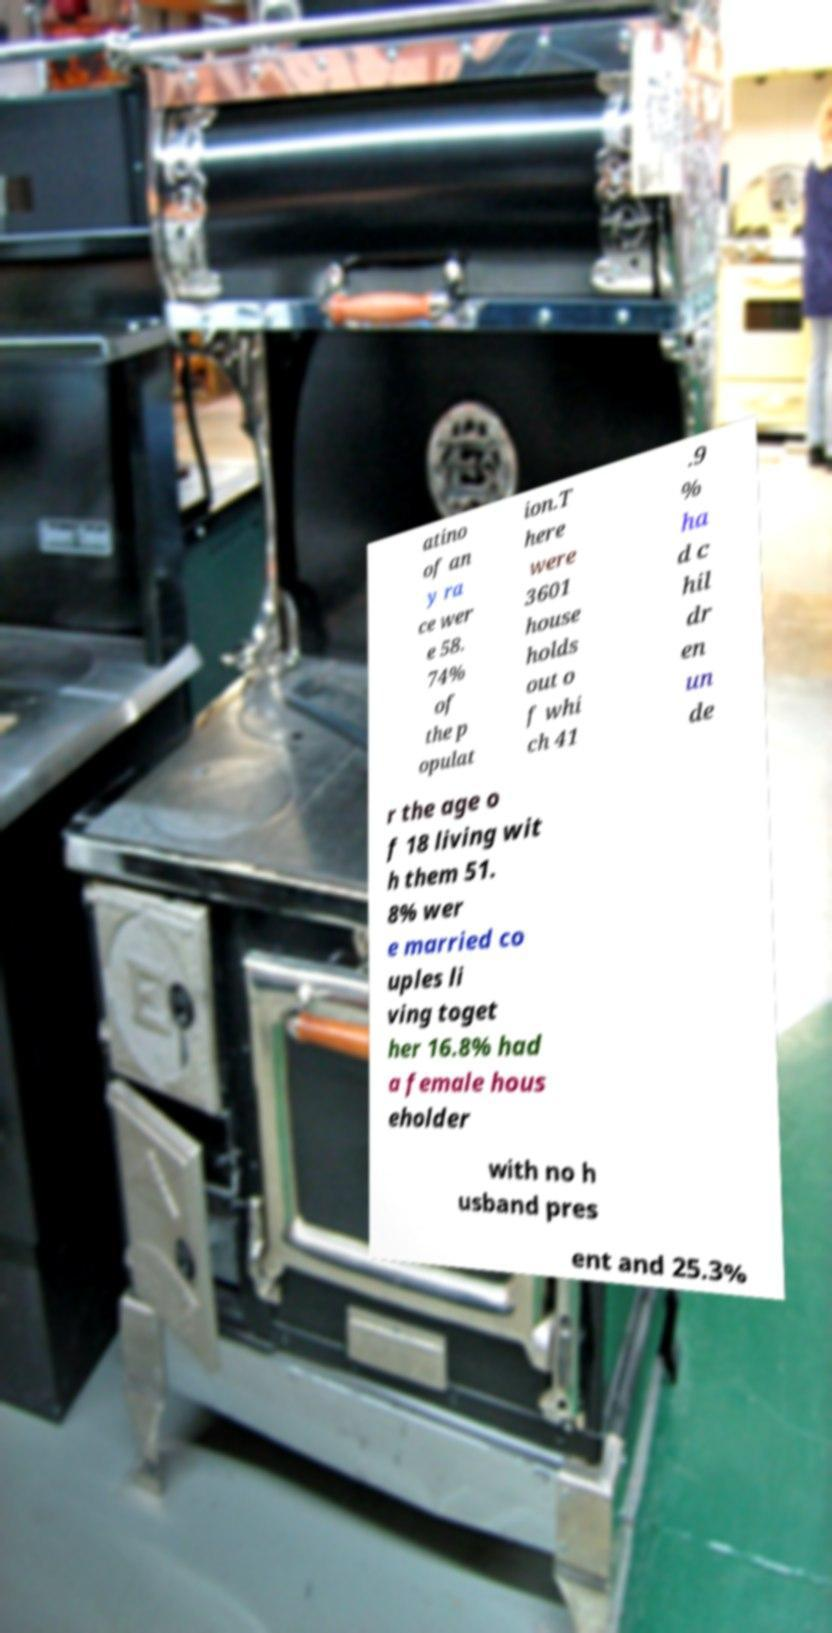Could you assist in decoding the text presented in this image and type it out clearly? atino of an y ra ce wer e 58. 74% of the p opulat ion.T here were 3601 house holds out o f whi ch 41 .9 % ha d c hil dr en un de r the age o f 18 living wit h them 51. 8% wer e married co uples li ving toget her 16.8% had a female hous eholder with no h usband pres ent and 25.3% 